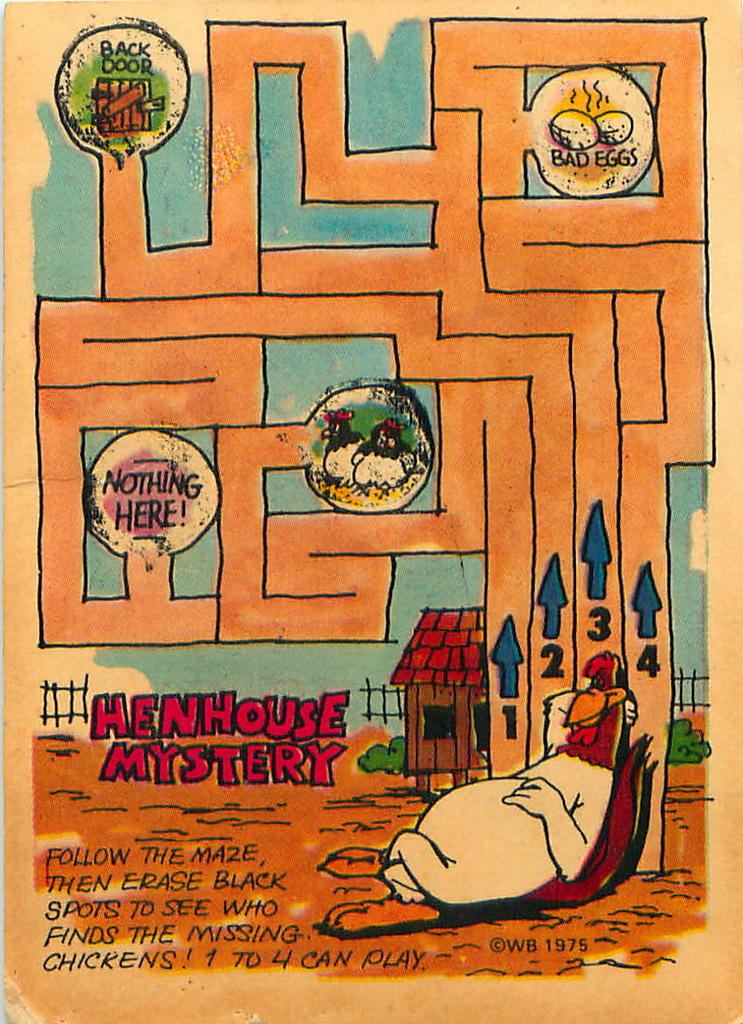What is the name of this game?
Your answer should be very brief. Henhouse mystery. What is the date shown?
Ensure brevity in your answer.  1975. 